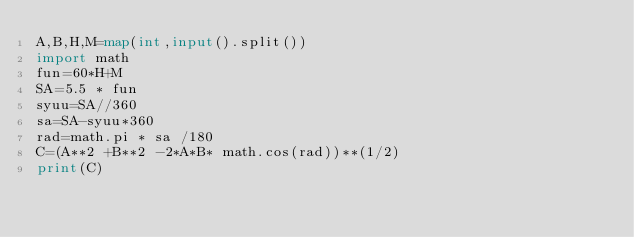Convert code to text. <code><loc_0><loc_0><loc_500><loc_500><_Python_>A,B,H,M=map(int,input().split())
import math
fun=60*H+M
SA=5.5 * fun
syuu=SA//360
sa=SA-syuu*360
rad=math.pi * sa /180
C=(A**2 +B**2 -2*A*B* math.cos(rad))**(1/2)
print(C)</code> 